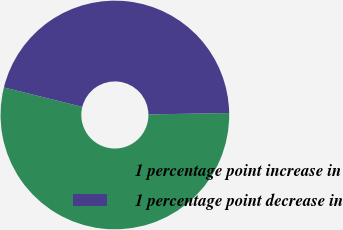Convert chart. <chart><loc_0><loc_0><loc_500><loc_500><pie_chart><fcel>1 percentage point increase in<fcel>1 percentage point decrease in<nl><fcel>54.14%<fcel>45.86%<nl></chart> 